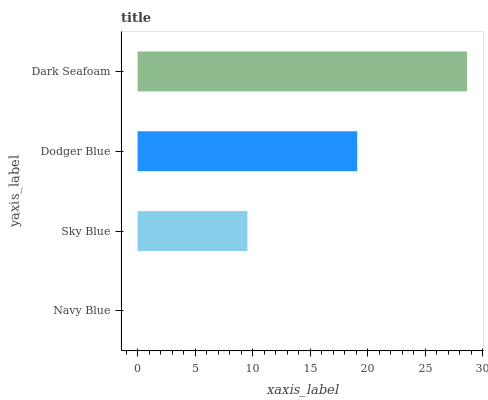Is Navy Blue the minimum?
Answer yes or no. Yes. Is Dark Seafoam the maximum?
Answer yes or no. Yes. Is Sky Blue the minimum?
Answer yes or no. No. Is Sky Blue the maximum?
Answer yes or no. No. Is Sky Blue greater than Navy Blue?
Answer yes or no. Yes. Is Navy Blue less than Sky Blue?
Answer yes or no. Yes. Is Navy Blue greater than Sky Blue?
Answer yes or no. No. Is Sky Blue less than Navy Blue?
Answer yes or no. No. Is Dodger Blue the high median?
Answer yes or no. Yes. Is Sky Blue the low median?
Answer yes or no. Yes. Is Navy Blue the high median?
Answer yes or no. No. Is Navy Blue the low median?
Answer yes or no. No. 